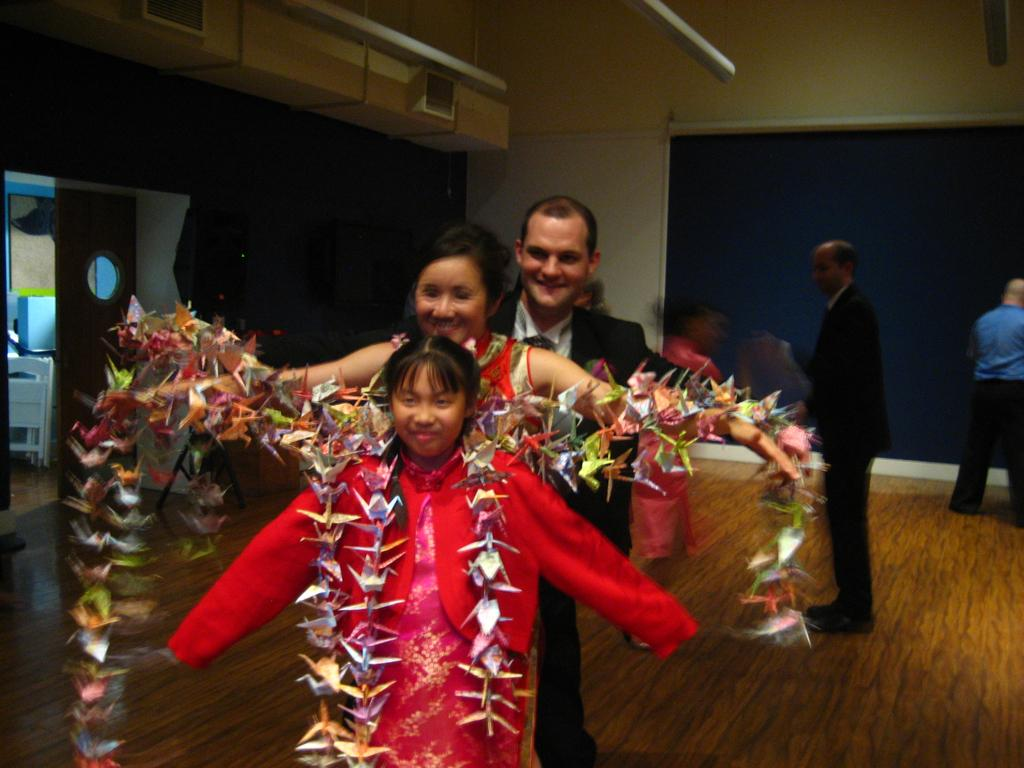What are the main subjects in the image? There are persons standing in the center of the image. Where are the persons standing? The persons are standing on the floor. What can be seen in the background of the image? There is a door, a screen, an air conditioner, and a wall in the background of the image. What time of day is it in the image, and how does it relate to the persons' pockets? The time of day is not mentioned in the image, and there is no information about the persons' pockets. 